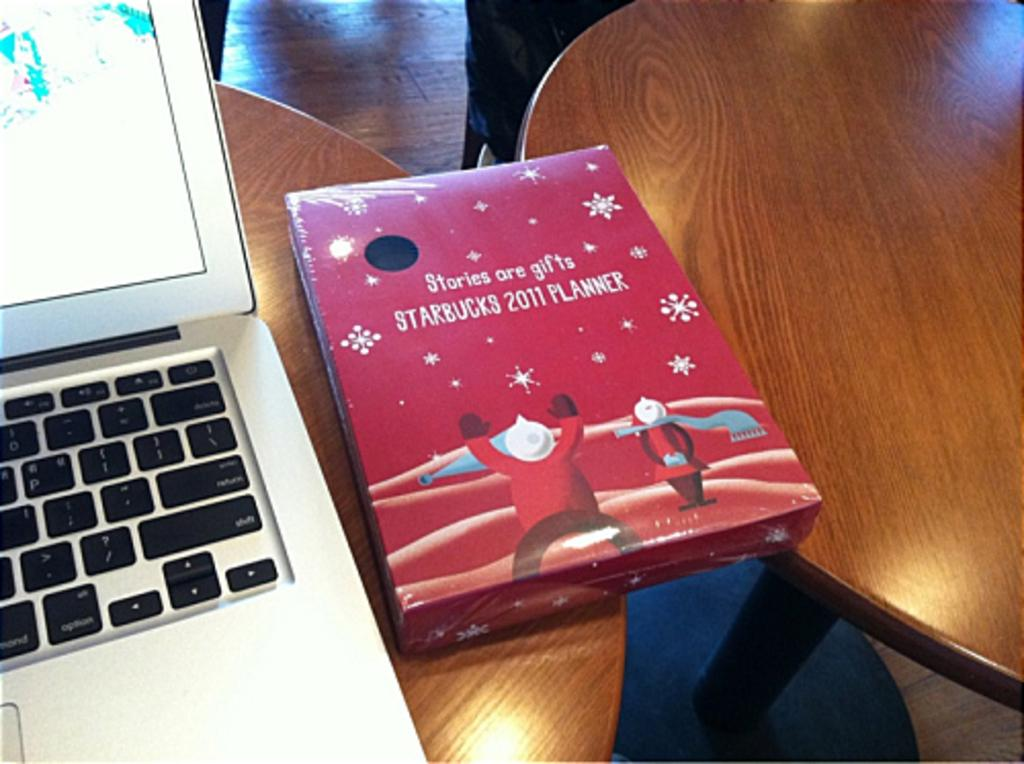What electronic device is visible in the image? There is a laptop in the image. What other object can be seen in the image? There is a box in the image. Where is the box located? The box is on a table. What type of furniture is present in the image? There is a chair in the image. How is the chair positioned in the image? The chair is on the floor. What type of force is being exerted on the laptop in the image? There is no indication of any force being exerted on the laptop in the image; it appears to be resting on a surface. 